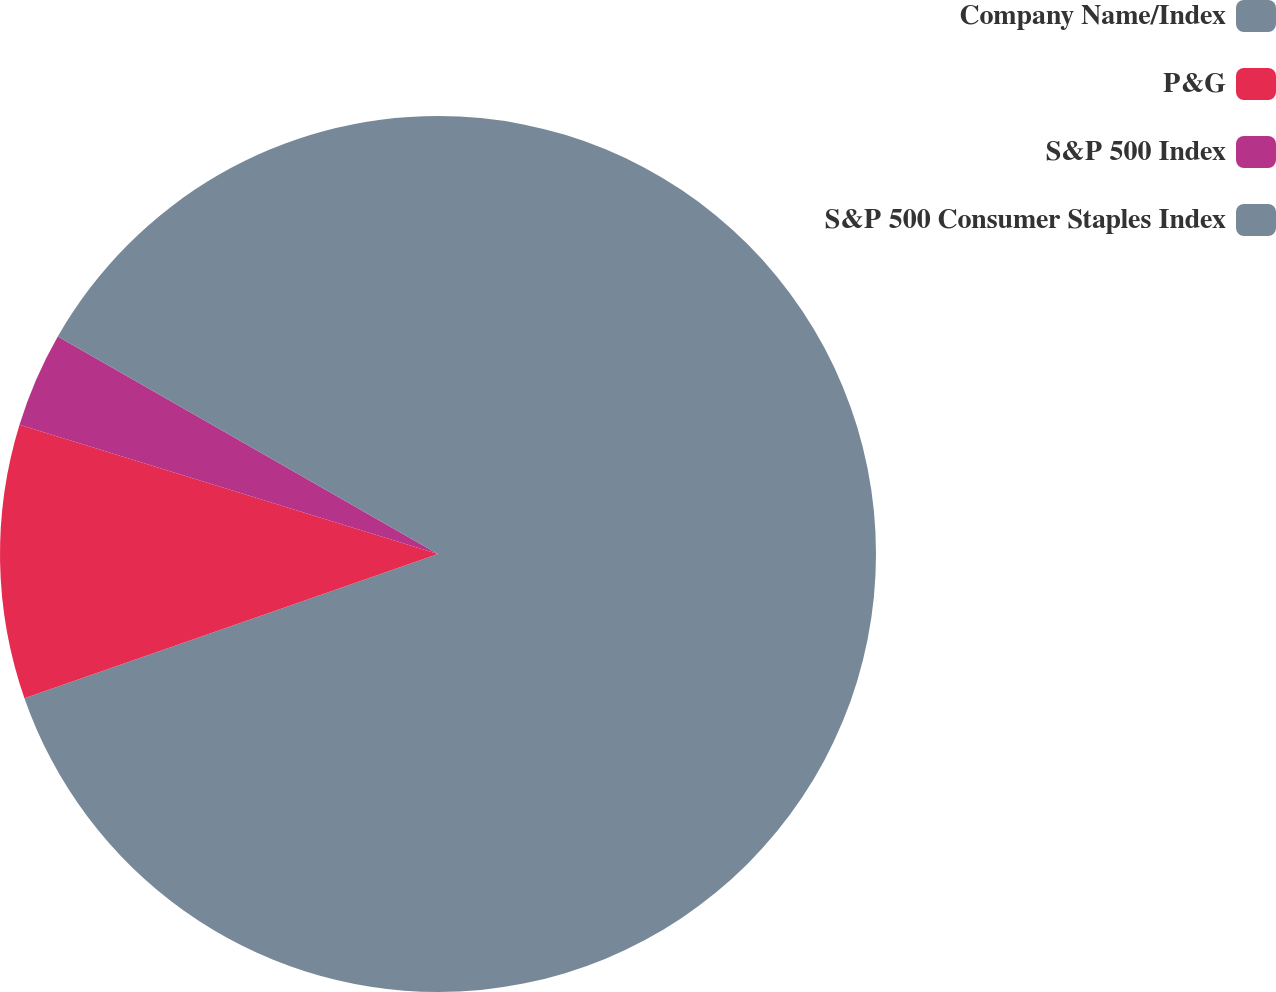<chart> <loc_0><loc_0><loc_500><loc_500><pie_chart><fcel>Company Name/Index<fcel>P&G<fcel>S&P 500 Index<fcel>S&P 500 Consumer Staples Index<nl><fcel>69.66%<fcel>10.11%<fcel>3.5%<fcel>16.73%<nl></chart> 